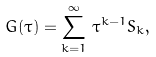Convert formula to latex. <formula><loc_0><loc_0><loc_500><loc_500>G ( \tau ) = \sum _ { k = 1 } ^ { \infty } \, \tau ^ { k - 1 } S _ { k } ,</formula> 